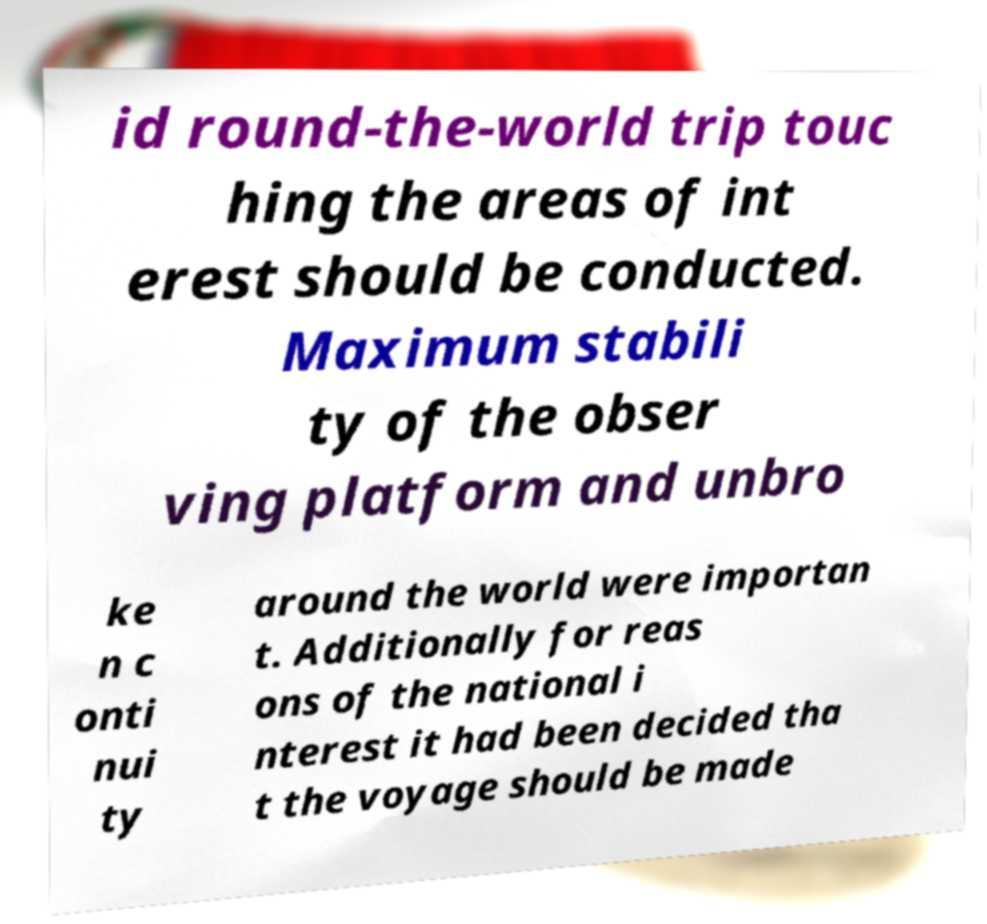For documentation purposes, I need the text within this image transcribed. Could you provide that? id round-the-world trip touc hing the areas of int erest should be conducted. Maximum stabili ty of the obser ving platform and unbro ke n c onti nui ty around the world were importan t. Additionally for reas ons of the national i nterest it had been decided tha t the voyage should be made 